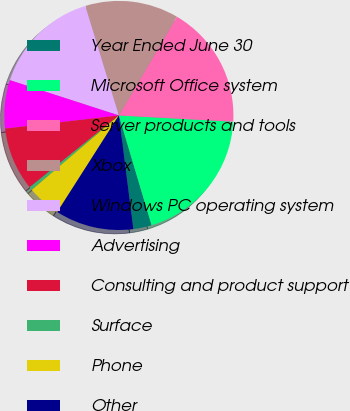Convert chart to OTSL. <chart><loc_0><loc_0><loc_500><loc_500><pie_chart><fcel>Year Ended June 30<fcel>Microsoft Office system<fcel>Server products and tools<fcel>Xbox<fcel>Windows PC operating system<fcel>Advertising<fcel>Consulting and product support<fcel>Surface<fcel>Phone<fcel>Other<nl><fcel>2.59%<fcel>19.53%<fcel>17.41%<fcel>13.18%<fcel>15.29%<fcel>6.82%<fcel>8.94%<fcel>0.47%<fcel>4.71%<fcel>11.06%<nl></chart> 